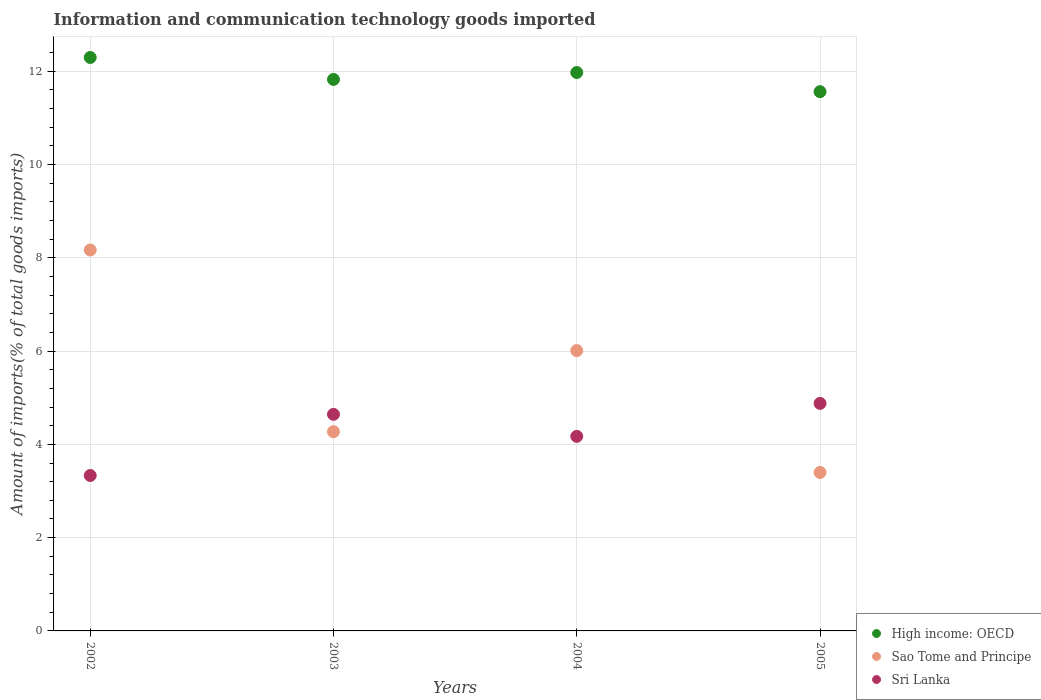What is the amount of goods imported in High income: OECD in 2002?
Give a very brief answer. 12.3. Across all years, what is the maximum amount of goods imported in Sri Lanka?
Offer a terse response. 4.88. Across all years, what is the minimum amount of goods imported in Sao Tome and Principe?
Provide a short and direct response. 3.4. In which year was the amount of goods imported in Sri Lanka maximum?
Ensure brevity in your answer.  2005. What is the total amount of goods imported in Sao Tome and Principe in the graph?
Ensure brevity in your answer.  21.85. What is the difference between the amount of goods imported in Sao Tome and Principe in 2002 and that in 2005?
Provide a short and direct response. 4.77. What is the difference between the amount of goods imported in Sri Lanka in 2004 and the amount of goods imported in Sao Tome and Principe in 2003?
Make the answer very short. -0.1. What is the average amount of goods imported in Sao Tome and Principe per year?
Ensure brevity in your answer.  5.46. In the year 2002, what is the difference between the amount of goods imported in Sao Tome and Principe and amount of goods imported in High income: OECD?
Provide a succinct answer. -4.13. In how many years, is the amount of goods imported in Sri Lanka greater than 0.8 %?
Your answer should be very brief. 4. What is the ratio of the amount of goods imported in Sao Tome and Principe in 2002 to that in 2004?
Ensure brevity in your answer.  1.36. Is the amount of goods imported in High income: OECD in 2003 less than that in 2005?
Keep it short and to the point. No. What is the difference between the highest and the second highest amount of goods imported in High income: OECD?
Give a very brief answer. 0.32. What is the difference between the highest and the lowest amount of goods imported in Sao Tome and Principe?
Make the answer very short. 4.77. Is the sum of the amount of goods imported in Sri Lanka in 2004 and 2005 greater than the maximum amount of goods imported in High income: OECD across all years?
Provide a short and direct response. No. Is it the case that in every year, the sum of the amount of goods imported in Sao Tome and Principe and amount of goods imported in High income: OECD  is greater than the amount of goods imported in Sri Lanka?
Ensure brevity in your answer.  Yes. Is the amount of goods imported in Sao Tome and Principe strictly greater than the amount of goods imported in Sri Lanka over the years?
Offer a terse response. No. Is the amount of goods imported in High income: OECD strictly less than the amount of goods imported in Sri Lanka over the years?
Your answer should be very brief. No. How many years are there in the graph?
Your response must be concise. 4. What is the difference between two consecutive major ticks on the Y-axis?
Give a very brief answer. 2. Are the values on the major ticks of Y-axis written in scientific E-notation?
Your answer should be compact. No. Does the graph contain grids?
Your response must be concise. Yes. How are the legend labels stacked?
Your answer should be compact. Vertical. What is the title of the graph?
Your answer should be compact. Information and communication technology goods imported. What is the label or title of the Y-axis?
Keep it short and to the point. Amount of imports(% of total goods imports). What is the Amount of imports(% of total goods imports) in High income: OECD in 2002?
Make the answer very short. 12.3. What is the Amount of imports(% of total goods imports) of Sao Tome and Principe in 2002?
Make the answer very short. 8.17. What is the Amount of imports(% of total goods imports) in Sri Lanka in 2002?
Make the answer very short. 3.33. What is the Amount of imports(% of total goods imports) of High income: OECD in 2003?
Give a very brief answer. 11.82. What is the Amount of imports(% of total goods imports) in Sao Tome and Principe in 2003?
Your answer should be very brief. 4.27. What is the Amount of imports(% of total goods imports) of Sri Lanka in 2003?
Make the answer very short. 4.64. What is the Amount of imports(% of total goods imports) of High income: OECD in 2004?
Make the answer very short. 11.97. What is the Amount of imports(% of total goods imports) of Sao Tome and Principe in 2004?
Offer a very short reply. 6.01. What is the Amount of imports(% of total goods imports) in Sri Lanka in 2004?
Provide a succinct answer. 4.17. What is the Amount of imports(% of total goods imports) of High income: OECD in 2005?
Your answer should be compact. 11.56. What is the Amount of imports(% of total goods imports) of Sao Tome and Principe in 2005?
Your answer should be very brief. 3.4. What is the Amount of imports(% of total goods imports) in Sri Lanka in 2005?
Offer a very short reply. 4.88. Across all years, what is the maximum Amount of imports(% of total goods imports) of High income: OECD?
Keep it short and to the point. 12.3. Across all years, what is the maximum Amount of imports(% of total goods imports) of Sao Tome and Principe?
Offer a very short reply. 8.17. Across all years, what is the maximum Amount of imports(% of total goods imports) of Sri Lanka?
Make the answer very short. 4.88. Across all years, what is the minimum Amount of imports(% of total goods imports) in High income: OECD?
Ensure brevity in your answer.  11.56. Across all years, what is the minimum Amount of imports(% of total goods imports) in Sao Tome and Principe?
Ensure brevity in your answer.  3.4. Across all years, what is the minimum Amount of imports(% of total goods imports) in Sri Lanka?
Provide a short and direct response. 3.33. What is the total Amount of imports(% of total goods imports) of High income: OECD in the graph?
Offer a very short reply. 47.66. What is the total Amount of imports(% of total goods imports) in Sao Tome and Principe in the graph?
Keep it short and to the point. 21.85. What is the total Amount of imports(% of total goods imports) in Sri Lanka in the graph?
Your response must be concise. 17.03. What is the difference between the Amount of imports(% of total goods imports) in High income: OECD in 2002 and that in 2003?
Provide a short and direct response. 0.47. What is the difference between the Amount of imports(% of total goods imports) of Sao Tome and Principe in 2002 and that in 2003?
Make the answer very short. 3.9. What is the difference between the Amount of imports(% of total goods imports) of Sri Lanka in 2002 and that in 2003?
Make the answer very short. -1.31. What is the difference between the Amount of imports(% of total goods imports) in High income: OECD in 2002 and that in 2004?
Offer a terse response. 0.32. What is the difference between the Amount of imports(% of total goods imports) in Sao Tome and Principe in 2002 and that in 2004?
Provide a short and direct response. 2.16. What is the difference between the Amount of imports(% of total goods imports) in Sri Lanka in 2002 and that in 2004?
Make the answer very short. -0.84. What is the difference between the Amount of imports(% of total goods imports) in High income: OECD in 2002 and that in 2005?
Provide a succinct answer. 0.73. What is the difference between the Amount of imports(% of total goods imports) of Sao Tome and Principe in 2002 and that in 2005?
Your answer should be compact. 4.77. What is the difference between the Amount of imports(% of total goods imports) in Sri Lanka in 2002 and that in 2005?
Provide a short and direct response. -1.55. What is the difference between the Amount of imports(% of total goods imports) in High income: OECD in 2003 and that in 2004?
Offer a terse response. -0.15. What is the difference between the Amount of imports(% of total goods imports) of Sao Tome and Principe in 2003 and that in 2004?
Your answer should be very brief. -1.74. What is the difference between the Amount of imports(% of total goods imports) of Sri Lanka in 2003 and that in 2004?
Offer a terse response. 0.47. What is the difference between the Amount of imports(% of total goods imports) in High income: OECD in 2003 and that in 2005?
Provide a succinct answer. 0.26. What is the difference between the Amount of imports(% of total goods imports) of Sao Tome and Principe in 2003 and that in 2005?
Ensure brevity in your answer.  0.87. What is the difference between the Amount of imports(% of total goods imports) in Sri Lanka in 2003 and that in 2005?
Give a very brief answer. -0.23. What is the difference between the Amount of imports(% of total goods imports) in High income: OECD in 2004 and that in 2005?
Offer a very short reply. 0.41. What is the difference between the Amount of imports(% of total goods imports) in Sao Tome and Principe in 2004 and that in 2005?
Provide a short and direct response. 2.61. What is the difference between the Amount of imports(% of total goods imports) of Sri Lanka in 2004 and that in 2005?
Keep it short and to the point. -0.71. What is the difference between the Amount of imports(% of total goods imports) in High income: OECD in 2002 and the Amount of imports(% of total goods imports) in Sao Tome and Principe in 2003?
Your answer should be compact. 8.02. What is the difference between the Amount of imports(% of total goods imports) in High income: OECD in 2002 and the Amount of imports(% of total goods imports) in Sri Lanka in 2003?
Provide a succinct answer. 7.65. What is the difference between the Amount of imports(% of total goods imports) of Sao Tome and Principe in 2002 and the Amount of imports(% of total goods imports) of Sri Lanka in 2003?
Make the answer very short. 3.52. What is the difference between the Amount of imports(% of total goods imports) in High income: OECD in 2002 and the Amount of imports(% of total goods imports) in Sao Tome and Principe in 2004?
Your response must be concise. 6.28. What is the difference between the Amount of imports(% of total goods imports) in High income: OECD in 2002 and the Amount of imports(% of total goods imports) in Sri Lanka in 2004?
Give a very brief answer. 8.12. What is the difference between the Amount of imports(% of total goods imports) of Sao Tome and Principe in 2002 and the Amount of imports(% of total goods imports) of Sri Lanka in 2004?
Ensure brevity in your answer.  4. What is the difference between the Amount of imports(% of total goods imports) in High income: OECD in 2002 and the Amount of imports(% of total goods imports) in Sao Tome and Principe in 2005?
Give a very brief answer. 8.9. What is the difference between the Amount of imports(% of total goods imports) of High income: OECD in 2002 and the Amount of imports(% of total goods imports) of Sri Lanka in 2005?
Offer a terse response. 7.42. What is the difference between the Amount of imports(% of total goods imports) in Sao Tome and Principe in 2002 and the Amount of imports(% of total goods imports) in Sri Lanka in 2005?
Offer a terse response. 3.29. What is the difference between the Amount of imports(% of total goods imports) in High income: OECD in 2003 and the Amount of imports(% of total goods imports) in Sao Tome and Principe in 2004?
Keep it short and to the point. 5.81. What is the difference between the Amount of imports(% of total goods imports) of High income: OECD in 2003 and the Amount of imports(% of total goods imports) of Sri Lanka in 2004?
Your answer should be compact. 7.65. What is the difference between the Amount of imports(% of total goods imports) of Sao Tome and Principe in 2003 and the Amount of imports(% of total goods imports) of Sri Lanka in 2004?
Your response must be concise. 0.1. What is the difference between the Amount of imports(% of total goods imports) of High income: OECD in 2003 and the Amount of imports(% of total goods imports) of Sao Tome and Principe in 2005?
Provide a short and direct response. 8.43. What is the difference between the Amount of imports(% of total goods imports) of High income: OECD in 2003 and the Amount of imports(% of total goods imports) of Sri Lanka in 2005?
Keep it short and to the point. 6.95. What is the difference between the Amount of imports(% of total goods imports) in Sao Tome and Principe in 2003 and the Amount of imports(% of total goods imports) in Sri Lanka in 2005?
Provide a short and direct response. -0.61. What is the difference between the Amount of imports(% of total goods imports) in High income: OECD in 2004 and the Amount of imports(% of total goods imports) in Sao Tome and Principe in 2005?
Ensure brevity in your answer.  8.58. What is the difference between the Amount of imports(% of total goods imports) in High income: OECD in 2004 and the Amount of imports(% of total goods imports) in Sri Lanka in 2005?
Keep it short and to the point. 7.09. What is the difference between the Amount of imports(% of total goods imports) in Sao Tome and Principe in 2004 and the Amount of imports(% of total goods imports) in Sri Lanka in 2005?
Ensure brevity in your answer.  1.13. What is the average Amount of imports(% of total goods imports) of High income: OECD per year?
Make the answer very short. 11.91. What is the average Amount of imports(% of total goods imports) of Sao Tome and Principe per year?
Provide a short and direct response. 5.46. What is the average Amount of imports(% of total goods imports) of Sri Lanka per year?
Provide a short and direct response. 4.26. In the year 2002, what is the difference between the Amount of imports(% of total goods imports) in High income: OECD and Amount of imports(% of total goods imports) in Sao Tome and Principe?
Provide a short and direct response. 4.13. In the year 2002, what is the difference between the Amount of imports(% of total goods imports) of High income: OECD and Amount of imports(% of total goods imports) of Sri Lanka?
Provide a succinct answer. 8.96. In the year 2002, what is the difference between the Amount of imports(% of total goods imports) of Sao Tome and Principe and Amount of imports(% of total goods imports) of Sri Lanka?
Keep it short and to the point. 4.84. In the year 2003, what is the difference between the Amount of imports(% of total goods imports) in High income: OECD and Amount of imports(% of total goods imports) in Sao Tome and Principe?
Make the answer very short. 7.55. In the year 2003, what is the difference between the Amount of imports(% of total goods imports) of High income: OECD and Amount of imports(% of total goods imports) of Sri Lanka?
Give a very brief answer. 7.18. In the year 2003, what is the difference between the Amount of imports(% of total goods imports) in Sao Tome and Principe and Amount of imports(% of total goods imports) in Sri Lanka?
Ensure brevity in your answer.  -0.37. In the year 2004, what is the difference between the Amount of imports(% of total goods imports) of High income: OECD and Amount of imports(% of total goods imports) of Sao Tome and Principe?
Ensure brevity in your answer.  5.96. In the year 2004, what is the difference between the Amount of imports(% of total goods imports) of High income: OECD and Amount of imports(% of total goods imports) of Sri Lanka?
Provide a short and direct response. 7.8. In the year 2004, what is the difference between the Amount of imports(% of total goods imports) of Sao Tome and Principe and Amount of imports(% of total goods imports) of Sri Lanka?
Provide a succinct answer. 1.84. In the year 2005, what is the difference between the Amount of imports(% of total goods imports) of High income: OECD and Amount of imports(% of total goods imports) of Sao Tome and Principe?
Provide a short and direct response. 8.16. In the year 2005, what is the difference between the Amount of imports(% of total goods imports) in High income: OECD and Amount of imports(% of total goods imports) in Sri Lanka?
Keep it short and to the point. 6.68. In the year 2005, what is the difference between the Amount of imports(% of total goods imports) of Sao Tome and Principe and Amount of imports(% of total goods imports) of Sri Lanka?
Offer a very short reply. -1.48. What is the ratio of the Amount of imports(% of total goods imports) of High income: OECD in 2002 to that in 2003?
Your answer should be compact. 1.04. What is the ratio of the Amount of imports(% of total goods imports) in Sao Tome and Principe in 2002 to that in 2003?
Provide a succinct answer. 1.91. What is the ratio of the Amount of imports(% of total goods imports) of Sri Lanka in 2002 to that in 2003?
Your response must be concise. 0.72. What is the ratio of the Amount of imports(% of total goods imports) of High income: OECD in 2002 to that in 2004?
Offer a terse response. 1.03. What is the ratio of the Amount of imports(% of total goods imports) in Sao Tome and Principe in 2002 to that in 2004?
Make the answer very short. 1.36. What is the ratio of the Amount of imports(% of total goods imports) in Sri Lanka in 2002 to that in 2004?
Your answer should be compact. 0.8. What is the ratio of the Amount of imports(% of total goods imports) of High income: OECD in 2002 to that in 2005?
Provide a succinct answer. 1.06. What is the ratio of the Amount of imports(% of total goods imports) of Sao Tome and Principe in 2002 to that in 2005?
Give a very brief answer. 2.4. What is the ratio of the Amount of imports(% of total goods imports) of Sri Lanka in 2002 to that in 2005?
Keep it short and to the point. 0.68. What is the ratio of the Amount of imports(% of total goods imports) in High income: OECD in 2003 to that in 2004?
Offer a very short reply. 0.99. What is the ratio of the Amount of imports(% of total goods imports) in Sao Tome and Principe in 2003 to that in 2004?
Make the answer very short. 0.71. What is the ratio of the Amount of imports(% of total goods imports) of Sri Lanka in 2003 to that in 2004?
Your response must be concise. 1.11. What is the ratio of the Amount of imports(% of total goods imports) of High income: OECD in 2003 to that in 2005?
Provide a short and direct response. 1.02. What is the ratio of the Amount of imports(% of total goods imports) in Sao Tome and Principe in 2003 to that in 2005?
Your answer should be very brief. 1.26. What is the ratio of the Amount of imports(% of total goods imports) of Sri Lanka in 2003 to that in 2005?
Make the answer very short. 0.95. What is the ratio of the Amount of imports(% of total goods imports) of High income: OECD in 2004 to that in 2005?
Keep it short and to the point. 1.04. What is the ratio of the Amount of imports(% of total goods imports) in Sao Tome and Principe in 2004 to that in 2005?
Provide a short and direct response. 1.77. What is the ratio of the Amount of imports(% of total goods imports) in Sri Lanka in 2004 to that in 2005?
Make the answer very short. 0.86. What is the difference between the highest and the second highest Amount of imports(% of total goods imports) in High income: OECD?
Make the answer very short. 0.32. What is the difference between the highest and the second highest Amount of imports(% of total goods imports) of Sao Tome and Principe?
Your response must be concise. 2.16. What is the difference between the highest and the second highest Amount of imports(% of total goods imports) in Sri Lanka?
Ensure brevity in your answer.  0.23. What is the difference between the highest and the lowest Amount of imports(% of total goods imports) in High income: OECD?
Offer a terse response. 0.73. What is the difference between the highest and the lowest Amount of imports(% of total goods imports) of Sao Tome and Principe?
Ensure brevity in your answer.  4.77. What is the difference between the highest and the lowest Amount of imports(% of total goods imports) of Sri Lanka?
Offer a terse response. 1.55. 